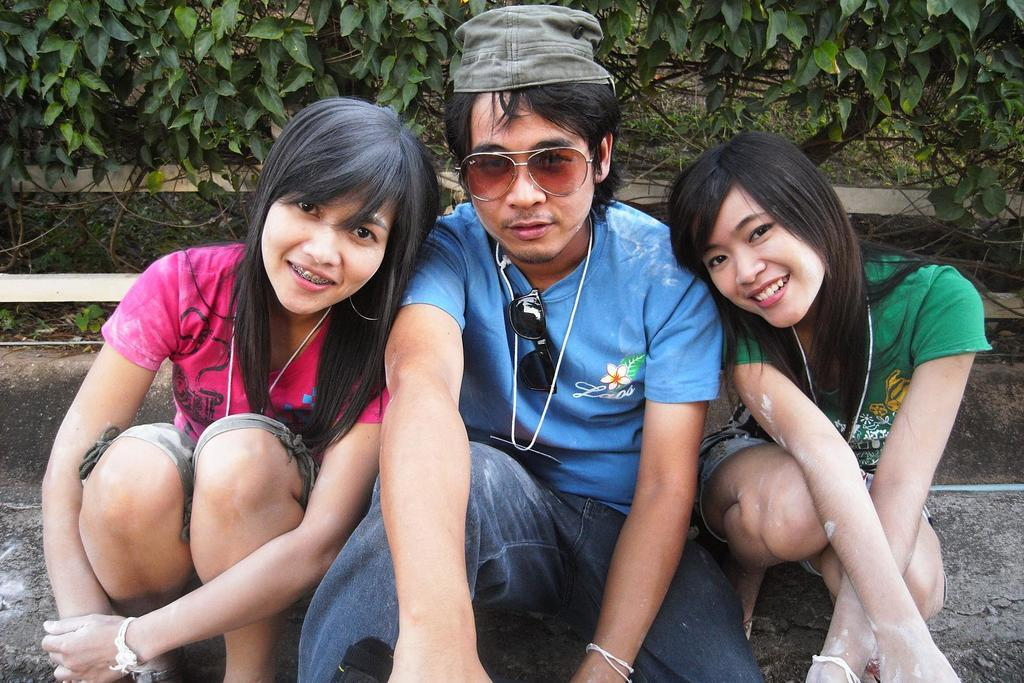What is the person in the image wearing? There is a person wearing a blue dress in the image. How many women are sitting on the ground in the image? There are two women sitting on the ground in the image. What can be seen in the background of the image? There are trees in the background of the image. What is the color of the trees in the image? The trees are green in color. What type of toy can be seen in the hands of the person wearing a blue dress in the image? There is no toy visible in the hands of the person wearing a blue dress in the image. 